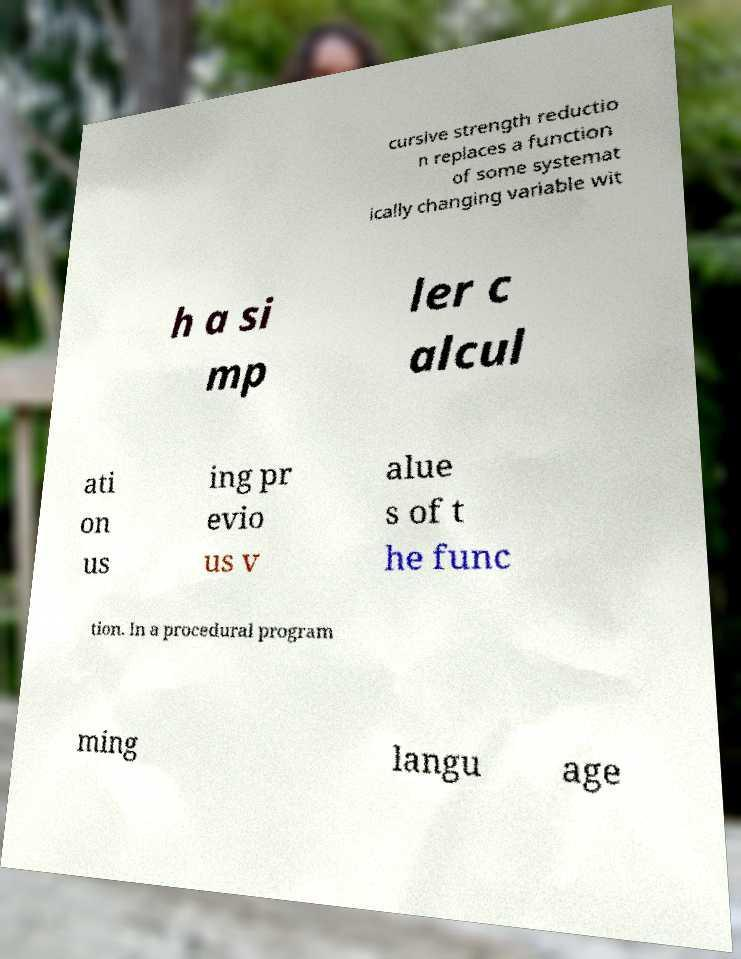Can you accurately transcribe the text from the provided image for me? cursive strength reductio n replaces a function of some systemat ically changing variable wit h a si mp ler c alcul ati on us ing pr evio us v alue s of t he func tion. In a procedural program ming langu age 